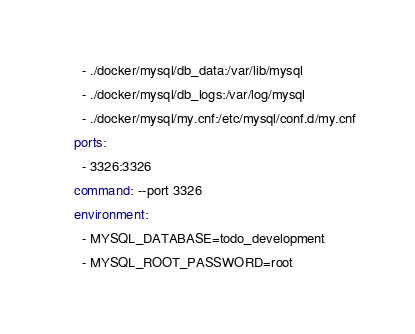Convert code to text. <code><loc_0><loc_0><loc_500><loc_500><_YAML_>      - ./docker/mysql/db_data:/var/lib/mysql
      - ./docker/mysql/db_logs:/var/log/mysql
      - ./docker/mysql/my.cnf:/etc/mysql/conf.d/my.cnf
    ports:
      - 3326:3326
    command: --port 3326
    environment:
      - MYSQL_DATABASE=todo_development
      - MYSQL_ROOT_PASSWORD=root
</code> 